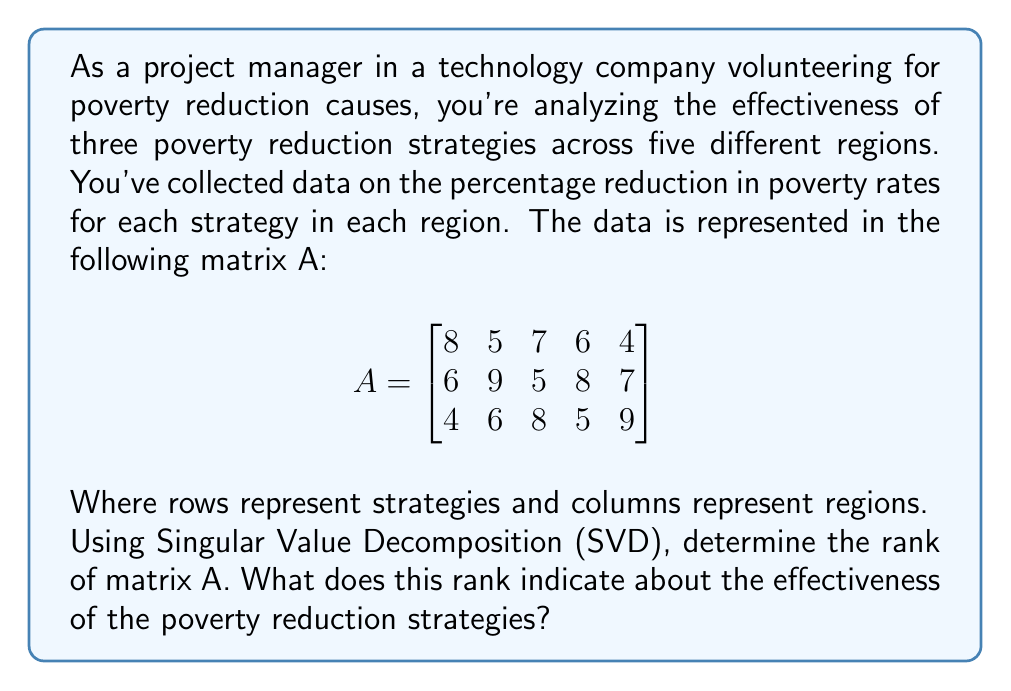Teach me how to tackle this problem. To solve this problem, we'll follow these steps:

1) Perform Singular Value Decomposition (SVD) on matrix A.
2) Determine the rank of A from its singular values.
3) Interpret the result in the context of poverty reduction strategies.

Step 1: Singular Value Decomposition

SVD decomposes A into the product of three matrices: $A = U\Sigma V^T$

Where:
- U is an m × m orthogonal matrix
- Σ is an m × n diagonal matrix with non-negative real numbers on the diagonal
- V^T is the transpose of an n × n orthogonal matrix V

Using a computational tool (as exact calculations are complex), we get:

$$\Sigma = \begin{bmatrix}
24.5362 & 0 & 0 & 0 & 0 \\
0 & 3.4641 & 0 & 0 & 0 \\
0 & 0 & 1.6996 & 0 & 0
\end{bmatrix}$$

Step 2: Determining the rank

The rank of A is equal to the number of non-zero singular values in Σ. From the Σ matrix, we can see that there are 3 non-zero singular values.

Therefore, the rank of A is 3.

Step 3: Interpretation

The rank of 3 indicates that:

1) All three strategies are linearly independent, meaning each strategy contributes unique information to poverty reduction efforts.
2) The effectiveness of the poverty reduction strategies can be fully described using three fundamental patterns or components.
3) There is no redundancy in the strategies; each strategy offers a distinct approach to poverty reduction.

This suggests that the current set of strategies is diverse and each plays a crucial role in the overall poverty reduction effort across the different regions.
Answer: Rank of A = 3; indicates all strategies are unique and essential. 